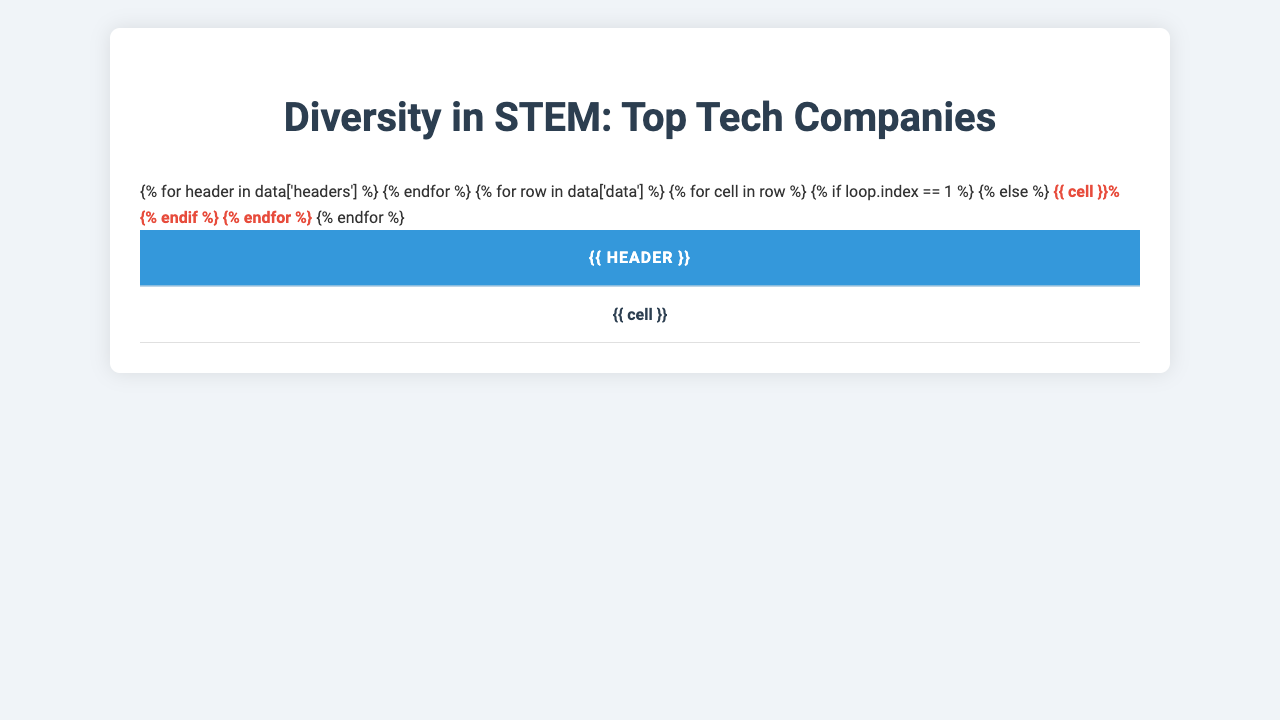What percentage of women are in tech roles at Salesforce? According to the table, Salesforce has 31.6% of women in tech roles.
Answer: 31.6% Which company has the highest percentage of employees with disabilities? Looking at the table, Salesforce has the highest percentage of employees with disabilities at 6.7%.
Answer: 6.7% Is the percentage of underrepresented minorities at Apple greater than that at Facebook? The table shows Apple has 14.2% underrepresented minorities, while Facebook has 5.2%, so yes, Apple's percentage is greater.
Answer: Yes What is the average percentage of women in tech roles across all the companies listed? The percentages for women in tech roles are 23.1, 20.6, 24.5, 26.3, 22.8, 28.7, 25.2, 27.5, 29.1, and 31.6. Adding these up gives 259.8; dividing by 10 gives an average of 25.98%.
Answer: 25.98% Which company has the lowest percentage of LGBTQ+ employees? In the table, Intel has the lowest percentage of LGBTQ+ employees at 3.9%.
Answer: 3.9% If we combine the percentage of women in tech roles and underrepresented minorities for Google, what is the total percentage? For Google, the percentage of women in tech roles is 23.1% and underrepresented minorities is 7.4%. Adding these gives a total of 30.5%.
Answer: 30.5% Is it true that all companies have over 20% women in tech roles? No, according to the table, Microsoft has only 20.6% women in tech roles, which is not over 20%.
Answer: No What percentage difference in underrepresented minorities exists between Apple and IBM? Apple has 14.2% and IBM has 12.3% underrepresented minorities. The difference is 14.2% - 12.3% = 1.9%.
Answer: 1.9% Which company has a higher percentage of LGBTQ+ employees, Google or Microsoft? Google has 5.9% and Microsoft has 4.8% of LGBTQ+ employees. Therefore, Google has a higher percentage.
Answer: Google If you compare Amazon and IBM, which company has a higher combined percentage of underrepresented minorities and employees with disabilities? Amazon has 11.9% underrepresented minorities and 5.9% disabilities, totaling 17.8%; IBM has 12.3% underrepresented minorities and 6.5% disabilities, totaling 18.8%. Thus, IBM has a higher combined percentage.
Answer: IBM 